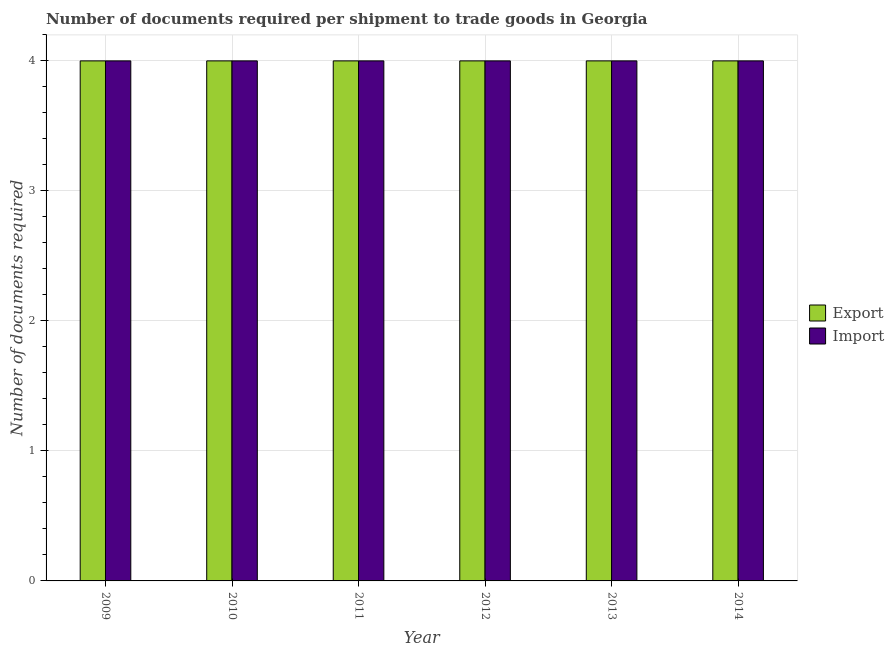How many different coloured bars are there?
Your answer should be compact. 2. How many groups of bars are there?
Ensure brevity in your answer.  6. Are the number of bars per tick equal to the number of legend labels?
Provide a short and direct response. Yes. Are the number of bars on each tick of the X-axis equal?
Keep it short and to the point. Yes. How many bars are there on the 4th tick from the right?
Make the answer very short. 2. What is the label of the 6th group of bars from the left?
Ensure brevity in your answer.  2014. What is the number of documents required to export goods in 2014?
Keep it short and to the point. 4. Across all years, what is the maximum number of documents required to import goods?
Offer a terse response. 4. Across all years, what is the minimum number of documents required to export goods?
Your response must be concise. 4. In which year was the number of documents required to import goods maximum?
Make the answer very short. 2009. In which year was the number of documents required to import goods minimum?
Offer a terse response. 2009. What is the total number of documents required to export goods in the graph?
Offer a terse response. 24. What is the difference between the number of documents required to import goods in 2012 and that in 2014?
Offer a very short reply. 0. What is the difference between the number of documents required to export goods in 2011 and the number of documents required to import goods in 2009?
Give a very brief answer. 0. What is the ratio of the number of documents required to import goods in 2009 to that in 2013?
Keep it short and to the point. 1. What is the difference between the highest and the lowest number of documents required to import goods?
Your answer should be compact. 0. In how many years, is the number of documents required to import goods greater than the average number of documents required to import goods taken over all years?
Keep it short and to the point. 0. Is the sum of the number of documents required to import goods in 2010 and 2011 greater than the maximum number of documents required to export goods across all years?
Provide a succinct answer. Yes. What does the 2nd bar from the left in 2010 represents?
Make the answer very short. Import. What does the 1st bar from the right in 2010 represents?
Make the answer very short. Import. Are all the bars in the graph horizontal?
Ensure brevity in your answer.  No. What is the difference between two consecutive major ticks on the Y-axis?
Offer a terse response. 1. Where does the legend appear in the graph?
Your answer should be very brief. Center right. What is the title of the graph?
Your answer should be very brief. Number of documents required per shipment to trade goods in Georgia. Does "Taxes on exports" appear as one of the legend labels in the graph?
Your response must be concise. No. What is the label or title of the X-axis?
Offer a terse response. Year. What is the label or title of the Y-axis?
Give a very brief answer. Number of documents required. What is the Number of documents required of Import in 2009?
Make the answer very short. 4. What is the Number of documents required of Export in 2010?
Your answer should be compact. 4. What is the Number of documents required in Export in 2011?
Ensure brevity in your answer.  4. What is the Number of documents required of Export in 2012?
Provide a short and direct response. 4. What is the Number of documents required of Import in 2012?
Give a very brief answer. 4. What is the Number of documents required of Import in 2013?
Give a very brief answer. 4. What is the total Number of documents required in Export in the graph?
Offer a terse response. 24. What is the difference between the Number of documents required of Import in 2009 and that in 2010?
Ensure brevity in your answer.  0. What is the difference between the Number of documents required of Export in 2009 and that in 2011?
Make the answer very short. 0. What is the difference between the Number of documents required of Import in 2009 and that in 2012?
Make the answer very short. 0. What is the difference between the Number of documents required in Import in 2009 and that in 2013?
Provide a short and direct response. 0. What is the difference between the Number of documents required in Export in 2009 and that in 2014?
Offer a terse response. 0. What is the difference between the Number of documents required in Export in 2010 and that in 2011?
Offer a terse response. 0. What is the difference between the Number of documents required in Import in 2010 and that in 2012?
Keep it short and to the point. 0. What is the difference between the Number of documents required in Export in 2010 and that in 2013?
Offer a very short reply. 0. What is the difference between the Number of documents required in Import in 2010 and that in 2013?
Make the answer very short. 0. What is the difference between the Number of documents required in Export in 2010 and that in 2014?
Your answer should be very brief. 0. What is the difference between the Number of documents required of Export in 2011 and that in 2013?
Offer a very short reply. 0. What is the difference between the Number of documents required in Import in 2011 and that in 2014?
Provide a short and direct response. 0. What is the difference between the Number of documents required of Export in 2012 and that in 2013?
Your answer should be compact. 0. What is the difference between the Number of documents required in Import in 2012 and that in 2013?
Keep it short and to the point. 0. What is the difference between the Number of documents required in Export in 2013 and that in 2014?
Provide a succinct answer. 0. What is the difference between the Number of documents required of Export in 2009 and the Number of documents required of Import in 2014?
Offer a terse response. 0. What is the difference between the Number of documents required of Export in 2010 and the Number of documents required of Import in 2014?
Keep it short and to the point. 0. What is the difference between the Number of documents required in Export in 2011 and the Number of documents required in Import in 2012?
Offer a terse response. 0. What is the difference between the Number of documents required in Export in 2011 and the Number of documents required in Import in 2013?
Provide a succinct answer. 0. What is the difference between the Number of documents required in Export in 2011 and the Number of documents required in Import in 2014?
Give a very brief answer. 0. What is the difference between the Number of documents required of Export in 2012 and the Number of documents required of Import in 2013?
Offer a terse response. 0. What is the difference between the Number of documents required in Export in 2012 and the Number of documents required in Import in 2014?
Provide a short and direct response. 0. What is the average Number of documents required of Export per year?
Make the answer very short. 4. What is the average Number of documents required of Import per year?
Offer a terse response. 4. In the year 2009, what is the difference between the Number of documents required of Export and Number of documents required of Import?
Offer a very short reply. 0. In the year 2010, what is the difference between the Number of documents required of Export and Number of documents required of Import?
Your response must be concise. 0. In the year 2014, what is the difference between the Number of documents required of Export and Number of documents required of Import?
Offer a very short reply. 0. What is the ratio of the Number of documents required of Export in 2009 to that in 2011?
Make the answer very short. 1. What is the ratio of the Number of documents required of Export in 2009 to that in 2012?
Offer a very short reply. 1. What is the ratio of the Number of documents required in Import in 2009 to that in 2013?
Ensure brevity in your answer.  1. What is the ratio of the Number of documents required of Export in 2009 to that in 2014?
Offer a very short reply. 1. What is the ratio of the Number of documents required of Import in 2009 to that in 2014?
Offer a terse response. 1. What is the ratio of the Number of documents required in Import in 2010 to that in 2011?
Provide a short and direct response. 1. What is the ratio of the Number of documents required in Export in 2010 to that in 2012?
Your answer should be very brief. 1. What is the ratio of the Number of documents required of Import in 2010 to that in 2012?
Offer a terse response. 1. What is the ratio of the Number of documents required of Export in 2010 to that in 2013?
Your answer should be compact. 1. What is the ratio of the Number of documents required of Import in 2010 to that in 2014?
Your response must be concise. 1. What is the ratio of the Number of documents required of Import in 2011 to that in 2012?
Make the answer very short. 1. What is the ratio of the Number of documents required of Export in 2011 to that in 2013?
Provide a succinct answer. 1. What is the ratio of the Number of documents required in Export in 2011 to that in 2014?
Provide a succinct answer. 1. What is the ratio of the Number of documents required of Export in 2012 to that in 2013?
Give a very brief answer. 1. What is the ratio of the Number of documents required of Import in 2012 to that in 2013?
Your answer should be very brief. 1. What is the ratio of the Number of documents required of Export in 2012 to that in 2014?
Your answer should be very brief. 1. What is the ratio of the Number of documents required in Export in 2013 to that in 2014?
Give a very brief answer. 1. What is the ratio of the Number of documents required in Import in 2013 to that in 2014?
Give a very brief answer. 1. 